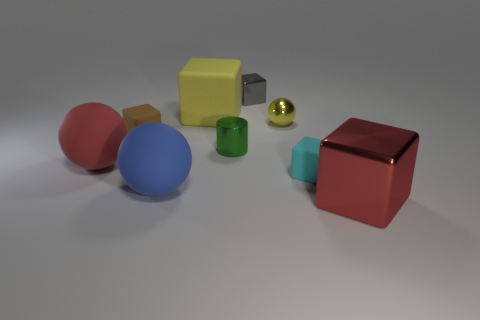There is a large object that is the same color as the large shiny cube; what shape is it?
Provide a short and direct response. Sphere. The cube that is the same color as the small ball is what size?
Offer a very short reply. Large. What number of other objects are there of the same size as the red cube?
Keep it short and to the point. 3. What color is the big cube that is left of the metallic block that is in front of the brown rubber thing behind the large blue thing?
Your answer should be very brief. Yellow. How many other objects are the same shape as the small green object?
Give a very brief answer. 0. The red thing left of the gray metallic object has what shape?
Your answer should be compact. Sphere. There is a large rubber thing that is on the left side of the tiny brown rubber block; is there a cyan rubber object left of it?
Your response must be concise. No. What color is the ball that is both to the right of the large red rubber ball and in front of the green thing?
Offer a terse response. Blue. Is there a large rubber thing to the right of the small metal ball that is left of the big thing that is to the right of the tiny gray object?
Provide a short and direct response. No. What is the size of the cyan object that is the same shape as the small brown matte thing?
Offer a terse response. Small. 